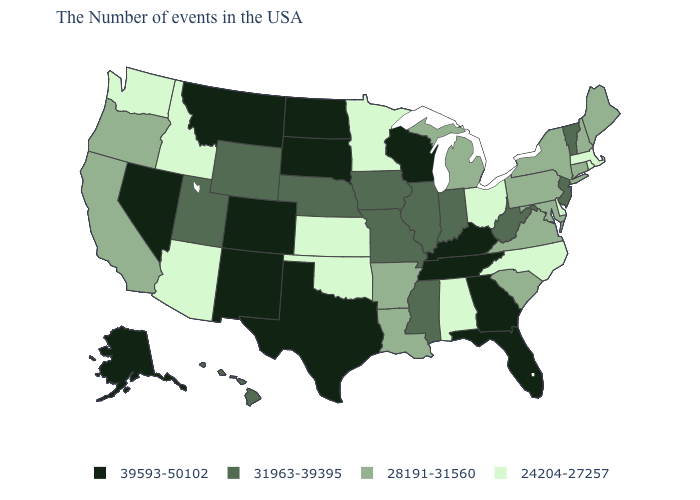Among the states that border Utah , which have the lowest value?
Concise answer only. Arizona, Idaho. Name the states that have a value in the range 24204-27257?
Keep it brief. Massachusetts, Rhode Island, Delaware, North Carolina, Ohio, Alabama, Minnesota, Kansas, Oklahoma, Arizona, Idaho, Washington. What is the value of North Carolina?
Write a very short answer. 24204-27257. Name the states that have a value in the range 31963-39395?
Answer briefly. Vermont, New Jersey, West Virginia, Indiana, Illinois, Mississippi, Missouri, Iowa, Nebraska, Wyoming, Utah, Hawaii. What is the value of Ohio?
Be succinct. 24204-27257. Does Rhode Island have the lowest value in the Northeast?
Short answer required. Yes. How many symbols are there in the legend?
Give a very brief answer. 4. Name the states that have a value in the range 24204-27257?
Keep it brief. Massachusetts, Rhode Island, Delaware, North Carolina, Ohio, Alabama, Minnesota, Kansas, Oklahoma, Arizona, Idaho, Washington. Does Minnesota have the lowest value in the MidWest?
Answer briefly. Yes. What is the value of Missouri?
Keep it brief. 31963-39395. Among the states that border Maryland , does Delaware have the lowest value?
Write a very short answer. Yes. What is the highest value in states that border Delaware?
Concise answer only. 31963-39395. Name the states that have a value in the range 28191-31560?
Keep it brief. Maine, New Hampshire, Connecticut, New York, Maryland, Pennsylvania, Virginia, South Carolina, Michigan, Louisiana, Arkansas, California, Oregon. 